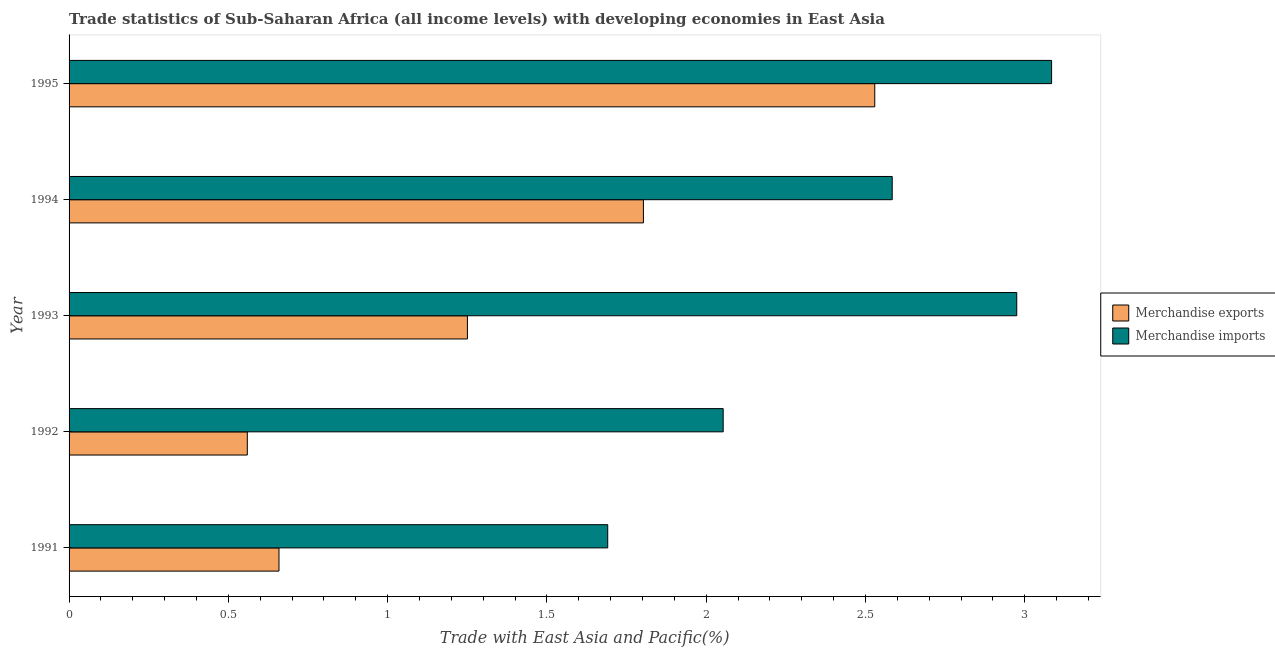How many different coloured bars are there?
Your response must be concise. 2. How many groups of bars are there?
Provide a short and direct response. 5. How many bars are there on the 2nd tick from the top?
Keep it short and to the point. 2. What is the label of the 2nd group of bars from the top?
Your answer should be very brief. 1994. What is the merchandise imports in 1991?
Your answer should be very brief. 1.69. Across all years, what is the maximum merchandise exports?
Give a very brief answer. 2.53. Across all years, what is the minimum merchandise imports?
Your answer should be very brief. 1.69. In which year was the merchandise exports minimum?
Offer a terse response. 1992. What is the total merchandise imports in the graph?
Keep it short and to the point. 12.39. What is the difference between the merchandise imports in 1992 and that in 1994?
Your answer should be very brief. -0.53. What is the difference between the merchandise exports in 1993 and the merchandise imports in 1991?
Ensure brevity in your answer.  -0.44. What is the average merchandise imports per year?
Make the answer very short. 2.48. In the year 1991, what is the difference between the merchandise exports and merchandise imports?
Give a very brief answer. -1.03. In how many years, is the merchandise imports greater than 0.7 %?
Provide a short and direct response. 5. What is the ratio of the merchandise imports in 1993 to that in 1995?
Give a very brief answer. 0.96. What is the difference between the highest and the second highest merchandise imports?
Offer a terse response. 0.11. What is the difference between the highest and the lowest merchandise imports?
Offer a very short reply. 1.39. What does the 2nd bar from the bottom in 1993 represents?
Keep it short and to the point. Merchandise imports. How many bars are there?
Provide a short and direct response. 10. How many years are there in the graph?
Provide a succinct answer. 5. Does the graph contain any zero values?
Offer a very short reply. No. Does the graph contain grids?
Your response must be concise. No. How many legend labels are there?
Make the answer very short. 2. What is the title of the graph?
Your answer should be very brief. Trade statistics of Sub-Saharan Africa (all income levels) with developing economies in East Asia. What is the label or title of the X-axis?
Ensure brevity in your answer.  Trade with East Asia and Pacific(%). What is the label or title of the Y-axis?
Your answer should be compact. Year. What is the Trade with East Asia and Pacific(%) of Merchandise exports in 1991?
Offer a terse response. 0.66. What is the Trade with East Asia and Pacific(%) in Merchandise imports in 1991?
Your response must be concise. 1.69. What is the Trade with East Asia and Pacific(%) of Merchandise exports in 1992?
Provide a short and direct response. 0.56. What is the Trade with East Asia and Pacific(%) in Merchandise imports in 1992?
Keep it short and to the point. 2.05. What is the Trade with East Asia and Pacific(%) of Merchandise exports in 1993?
Your answer should be very brief. 1.25. What is the Trade with East Asia and Pacific(%) of Merchandise imports in 1993?
Your answer should be compact. 2.97. What is the Trade with East Asia and Pacific(%) of Merchandise exports in 1994?
Offer a very short reply. 1.8. What is the Trade with East Asia and Pacific(%) in Merchandise imports in 1994?
Provide a short and direct response. 2.58. What is the Trade with East Asia and Pacific(%) in Merchandise exports in 1995?
Provide a short and direct response. 2.53. What is the Trade with East Asia and Pacific(%) in Merchandise imports in 1995?
Offer a terse response. 3.08. Across all years, what is the maximum Trade with East Asia and Pacific(%) in Merchandise exports?
Ensure brevity in your answer.  2.53. Across all years, what is the maximum Trade with East Asia and Pacific(%) in Merchandise imports?
Offer a very short reply. 3.08. Across all years, what is the minimum Trade with East Asia and Pacific(%) in Merchandise exports?
Offer a terse response. 0.56. Across all years, what is the minimum Trade with East Asia and Pacific(%) in Merchandise imports?
Your answer should be compact. 1.69. What is the total Trade with East Asia and Pacific(%) of Merchandise exports in the graph?
Provide a short and direct response. 6.8. What is the total Trade with East Asia and Pacific(%) in Merchandise imports in the graph?
Provide a succinct answer. 12.39. What is the difference between the Trade with East Asia and Pacific(%) in Merchandise exports in 1991 and that in 1992?
Your response must be concise. 0.1. What is the difference between the Trade with East Asia and Pacific(%) in Merchandise imports in 1991 and that in 1992?
Provide a succinct answer. -0.36. What is the difference between the Trade with East Asia and Pacific(%) in Merchandise exports in 1991 and that in 1993?
Provide a short and direct response. -0.59. What is the difference between the Trade with East Asia and Pacific(%) in Merchandise imports in 1991 and that in 1993?
Provide a short and direct response. -1.28. What is the difference between the Trade with East Asia and Pacific(%) of Merchandise exports in 1991 and that in 1994?
Offer a very short reply. -1.14. What is the difference between the Trade with East Asia and Pacific(%) in Merchandise imports in 1991 and that in 1994?
Keep it short and to the point. -0.89. What is the difference between the Trade with East Asia and Pacific(%) in Merchandise exports in 1991 and that in 1995?
Give a very brief answer. -1.87. What is the difference between the Trade with East Asia and Pacific(%) of Merchandise imports in 1991 and that in 1995?
Your answer should be very brief. -1.39. What is the difference between the Trade with East Asia and Pacific(%) of Merchandise exports in 1992 and that in 1993?
Keep it short and to the point. -0.69. What is the difference between the Trade with East Asia and Pacific(%) of Merchandise imports in 1992 and that in 1993?
Your response must be concise. -0.92. What is the difference between the Trade with East Asia and Pacific(%) in Merchandise exports in 1992 and that in 1994?
Your response must be concise. -1.24. What is the difference between the Trade with East Asia and Pacific(%) of Merchandise imports in 1992 and that in 1994?
Keep it short and to the point. -0.53. What is the difference between the Trade with East Asia and Pacific(%) in Merchandise exports in 1992 and that in 1995?
Keep it short and to the point. -1.97. What is the difference between the Trade with East Asia and Pacific(%) in Merchandise imports in 1992 and that in 1995?
Make the answer very short. -1.03. What is the difference between the Trade with East Asia and Pacific(%) in Merchandise exports in 1993 and that in 1994?
Your answer should be compact. -0.55. What is the difference between the Trade with East Asia and Pacific(%) in Merchandise imports in 1993 and that in 1994?
Keep it short and to the point. 0.39. What is the difference between the Trade with East Asia and Pacific(%) in Merchandise exports in 1993 and that in 1995?
Provide a short and direct response. -1.28. What is the difference between the Trade with East Asia and Pacific(%) of Merchandise imports in 1993 and that in 1995?
Make the answer very short. -0.11. What is the difference between the Trade with East Asia and Pacific(%) in Merchandise exports in 1994 and that in 1995?
Ensure brevity in your answer.  -0.73. What is the difference between the Trade with East Asia and Pacific(%) of Merchandise imports in 1994 and that in 1995?
Offer a very short reply. -0.5. What is the difference between the Trade with East Asia and Pacific(%) in Merchandise exports in 1991 and the Trade with East Asia and Pacific(%) in Merchandise imports in 1992?
Provide a succinct answer. -1.39. What is the difference between the Trade with East Asia and Pacific(%) of Merchandise exports in 1991 and the Trade with East Asia and Pacific(%) of Merchandise imports in 1993?
Your answer should be compact. -2.32. What is the difference between the Trade with East Asia and Pacific(%) of Merchandise exports in 1991 and the Trade with East Asia and Pacific(%) of Merchandise imports in 1994?
Provide a succinct answer. -1.93. What is the difference between the Trade with East Asia and Pacific(%) of Merchandise exports in 1991 and the Trade with East Asia and Pacific(%) of Merchandise imports in 1995?
Make the answer very short. -2.43. What is the difference between the Trade with East Asia and Pacific(%) of Merchandise exports in 1992 and the Trade with East Asia and Pacific(%) of Merchandise imports in 1993?
Ensure brevity in your answer.  -2.42. What is the difference between the Trade with East Asia and Pacific(%) of Merchandise exports in 1992 and the Trade with East Asia and Pacific(%) of Merchandise imports in 1994?
Make the answer very short. -2.02. What is the difference between the Trade with East Asia and Pacific(%) of Merchandise exports in 1992 and the Trade with East Asia and Pacific(%) of Merchandise imports in 1995?
Offer a very short reply. -2.52. What is the difference between the Trade with East Asia and Pacific(%) in Merchandise exports in 1993 and the Trade with East Asia and Pacific(%) in Merchandise imports in 1994?
Offer a very short reply. -1.33. What is the difference between the Trade with East Asia and Pacific(%) of Merchandise exports in 1993 and the Trade with East Asia and Pacific(%) of Merchandise imports in 1995?
Provide a succinct answer. -1.83. What is the difference between the Trade with East Asia and Pacific(%) in Merchandise exports in 1994 and the Trade with East Asia and Pacific(%) in Merchandise imports in 1995?
Provide a succinct answer. -1.28. What is the average Trade with East Asia and Pacific(%) of Merchandise exports per year?
Your answer should be compact. 1.36. What is the average Trade with East Asia and Pacific(%) in Merchandise imports per year?
Make the answer very short. 2.48. In the year 1991, what is the difference between the Trade with East Asia and Pacific(%) in Merchandise exports and Trade with East Asia and Pacific(%) in Merchandise imports?
Make the answer very short. -1.03. In the year 1992, what is the difference between the Trade with East Asia and Pacific(%) of Merchandise exports and Trade with East Asia and Pacific(%) of Merchandise imports?
Your answer should be compact. -1.49. In the year 1993, what is the difference between the Trade with East Asia and Pacific(%) in Merchandise exports and Trade with East Asia and Pacific(%) in Merchandise imports?
Give a very brief answer. -1.72. In the year 1994, what is the difference between the Trade with East Asia and Pacific(%) in Merchandise exports and Trade with East Asia and Pacific(%) in Merchandise imports?
Offer a very short reply. -0.78. In the year 1995, what is the difference between the Trade with East Asia and Pacific(%) of Merchandise exports and Trade with East Asia and Pacific(%) of Merchandise imports?
Give a very brief answer. -0.56. What is the ratio of the Trade with East Asia and Pacific(%) of Merchandise exports in 1991 to that in 1992?
Give a very brief answer. 1.18. What is the ratio of the Trade with East Asia and Pacific(%) in Merchandise imports in 1991 to that in 1992?
Provide a succinct answer. 0.82. What is the ratio of the Trade with East Asia and Pacific(%) in Merchandise exports in 1991 to that in 1993?
Give a very brief answer. 0.53. What is the ratio of the Trade with East Asia and Pacific(%) in Merchandise imports in 1991 to that in 1993?
Your response must be concise. 0.57. What is the ratio of the Trade with East Asia and Pacific(%) in Merchandise exports in 1991 to that in 1994?
Offer a very short reply. 0.37. What is the ratio of the Trade with East Asia and Pacific(%) in Merchandise imports in 1991 to that in 1994?
Give a very brief answer. 0.65. What is the ratio of the Trade with East Asia and Pacific(%) in Merchandise exports in 1991 to that in 1995?
Ensure brevity in your answer.  0.26. What is the ratio of the Trade with East Asia and Pacific(%) of Merchandise imports in 1991 to that in 1995?
Provide a short and direct response. 0.55. What is the ratio of the Trade with East Asia and Pacific(%) of Merchandise exports in 1992 to that in 1993?
Ensure brevity in your answer.  0.45. What is the ratio of the Trade with East Asia and Pacific(%) in Merchandise imports in 1992 to that in 1993?
Your answer should be very brief. 0.69. What is the ratio of the Trade with East Asia and Pacific(%) of Merchandise exports in 1992 to that in 1994?
Provide a short and direct response. 0.31. What is the ratio of the Trade with East Asia and Pacific(%) of Merchandise imports in 1992 to that in 1994?
Your response must be concise. 0.79. What is the ratio of the Trade with East Asia and Pacific(%) in Merchandise exports in 1992 to that in 1995?
Keep it short and to the point. 0.22. What is the ratio of the Trade with East Asia and Pacific(%) of Merchandise imports in 1992 to that in 1995?
Provide a short and direct response. 0.67. What is the ratio of the Trade with East Asia and Pacific(%) in Merchandise exports in 1993 to that in 1994?
Offer a terse response. 0.69. What is the ratio of the Trade with East Asia and Pacific(%) in Merchandise imports in 1993 to that in 1994?
Your answer should be compact. 1.15. What is the ratio of the Trade with East Asia and Pacific(%) in Merchandise exports in 1993 to that in 1995?
Keep it short and to the point. 0.49. What is the ratio of the Trade with East Asia and Pacific(%) of Merchandise imports in 1993 to that in 1995?
Provide a short and direct response. 0.96. What is the ratio of the Trade with East Asia and Pacific(%) of Merchandise exports in 1994 to that in 1995?
Keep it short and to the point. 0.71. What is the ratio of the Trade with East Asia and Pacific(%) of Merchandise imports in 1994 to that in 1995?
Your answer should be very brief. 0.84. What is the difference between the highest and the second highest Trade with East Asia and Pacific(%) in Merchandise exports?
Your answer should be compact. 0.73. What is the difference between the highest and the second highest Trade with East Asia and Pacific(%) in Merchandise imports?
Your answer should be very brief. 0.11. What is the difference between the highest and the lowest Trade with East Asia and Pacific(%) of Merchandise exports?
Offer a terse response. 1.97. What is the difference between the highest and the lowest Trade with East Asia and Pacific(%) of Merchandise imports?
Provide a succinct answer. 1.39. 